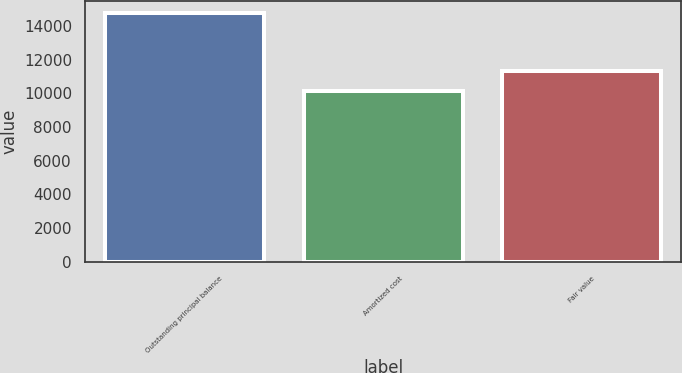Convert chart. <chart><loc_0><loc_0><loc_500><loc_500><bar_chart><fcel>Outstanding principal balance<fcel>Amortized cost<fcel>Fair value<nl><fcel>14741<fcel>10110<fcel>11338<nl></chart> 